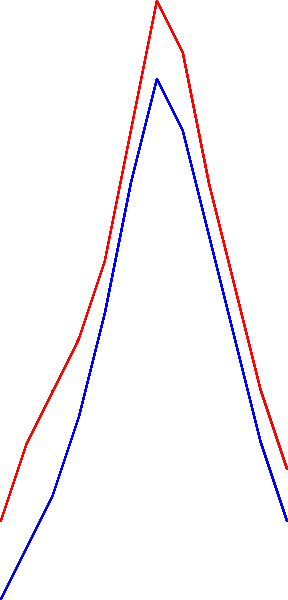Based on the time series graph showing average flight delays for two airlines over a year, what conclusions can be drawn about their operational performance during peak travel seasons? To analyze the operational performance of the two airlines during peak travel seasons, we need to follow these steps:

1. Identify peak travel seasons:
   - Summer: typically June to August (months 6-8)
   - Winter holidays: December to January (months 12 and 1)

2. Compare delay patterns during these periods:
   - Summer (months 6-8):
     Airline A: Peaks at 35 minutes in month 7
     Airline B: Peaks at 32 minutes in month 7

   - Winter (months 12 and 1):
     Airline A: 17 minutes in month 12, 15 minutes in month 1
     Airline B: 15 minutes in month 12, 12 minutes in month 1

3. Analyze the differences:
   - Both airlines show similar patterns with higher delays in summer
   - Airline A consistently has slightly higher delays than Airline B
   - The difference is more pronounced during peak seasons
   - Both airlines manage winter holiday traffic better than summer traffic

4. Consider possible reasons:
   - Summer delays could be due to increased passenger volume and weather issues
   - Better winter performance might be due to proactive planning for holiday travel

5. Operational performance conclusion:
   - Both airlines struggle more with summer peak season than winter
   - Airline B appears to have slightly better operational performance in managing delays during peak seasons
Answer: Airline B demonstrates marginally better operational performance during peak seasons, with both airlines handling winter holiday traffic more efficiently than summer peak travel. 